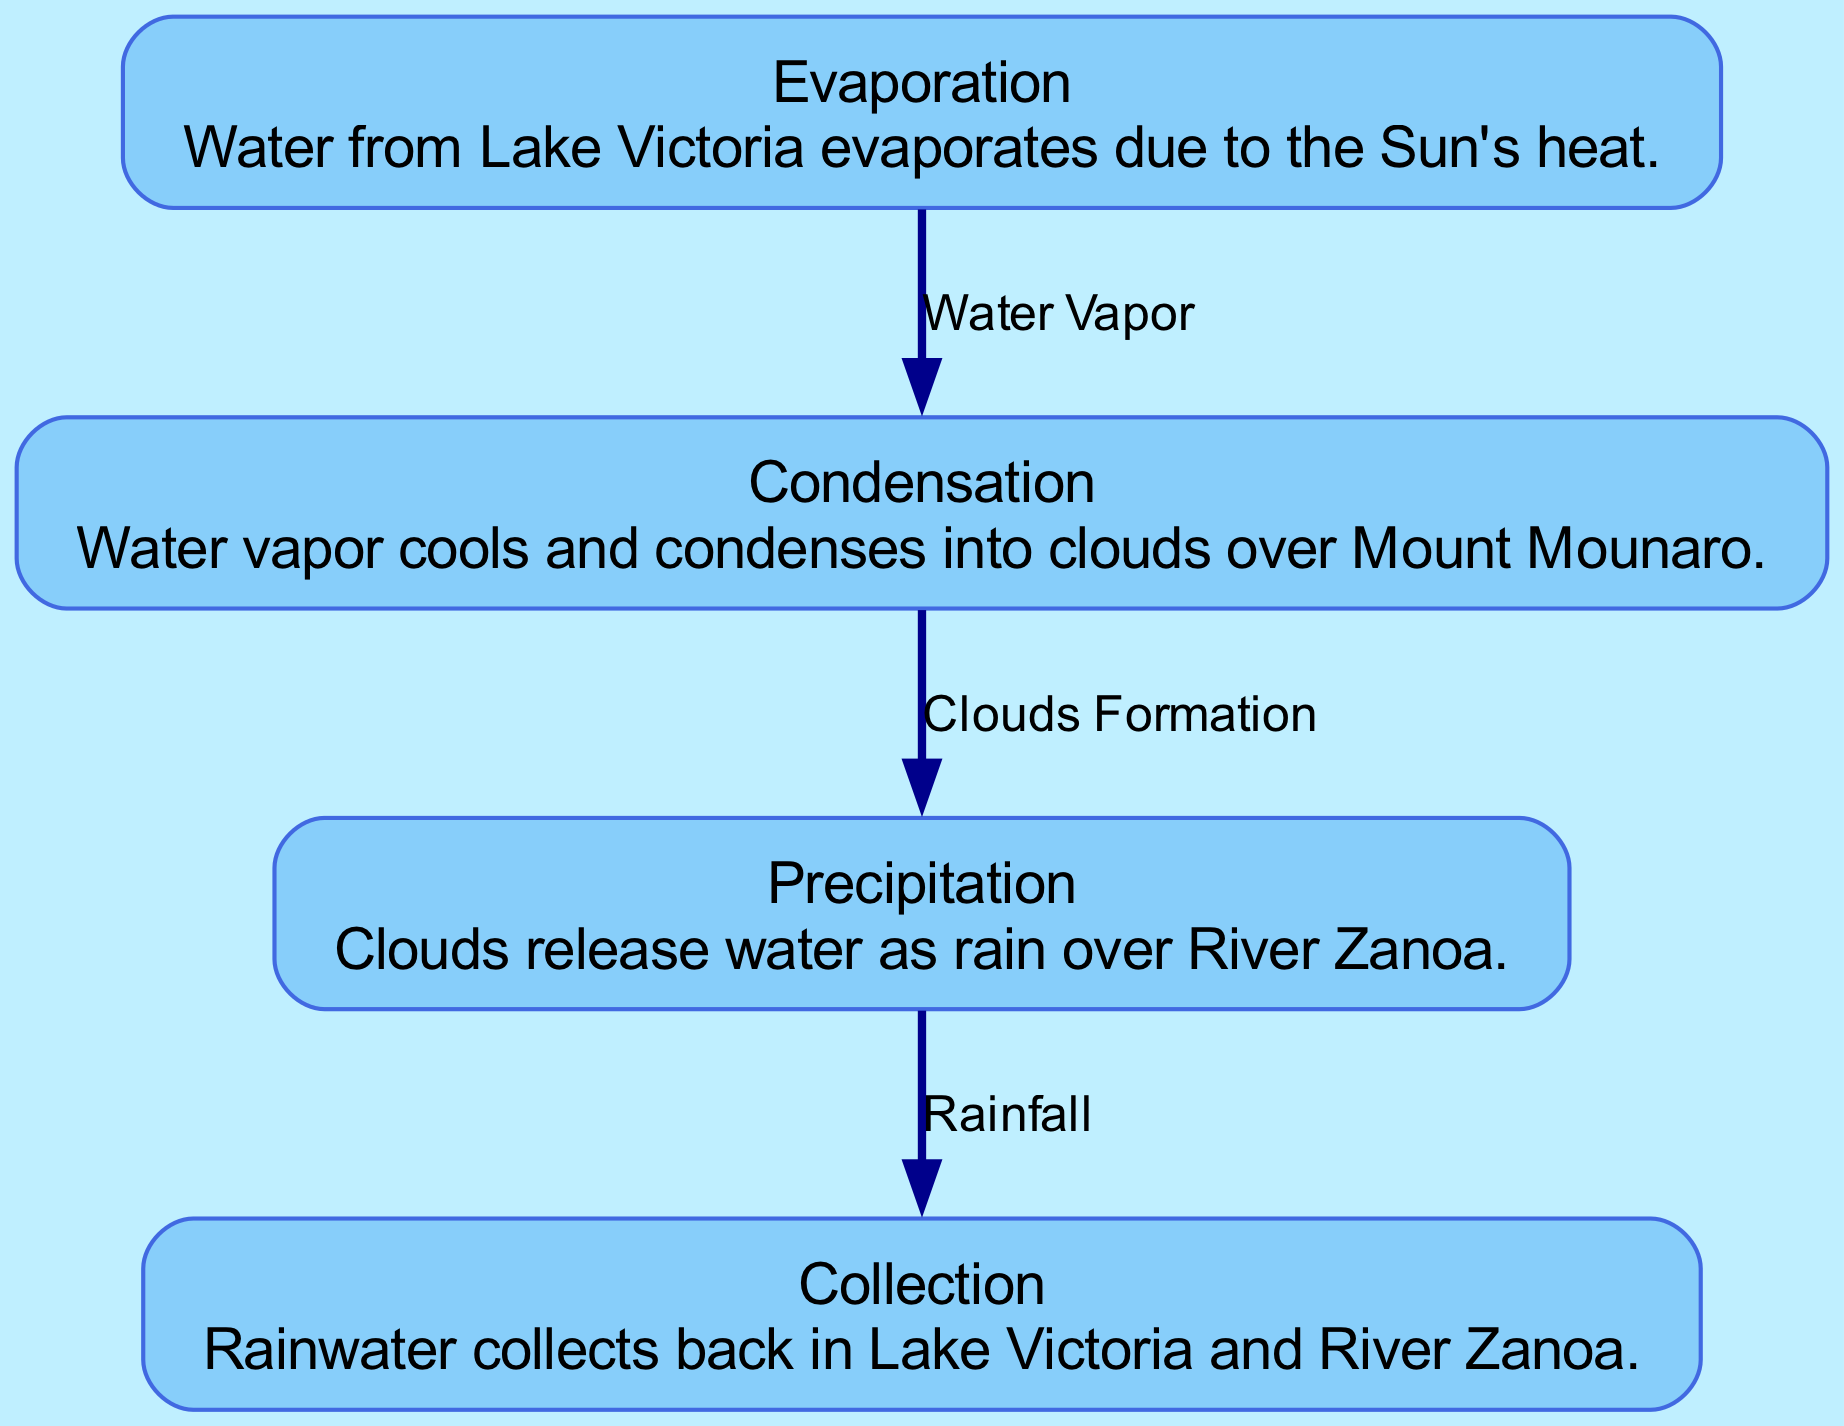What is the first process in the water cycle shown in the diagram? The first process listed in the nodes of the diagram is "Evaporation," which indicates that water evaporates from Lake Victoria due to the Sun's heat.
Answer: Evaporation How many nodes are depicted in the diagram? By counting the individual processes represented in the diagram, which are Evaporation, Condensation, Precipitation, and Collection, there are a total of four nodes.
Answer: 4 What do clouds form from in the water cycle? According to the edges in the diagram, clouds form from the "Water Vapor" produced during the Evaporation process.
Answer: Water Vapor Which local water source is mentioned during the precipitation process? The diagram specifically mentions "River Zanoa" in relation to the precipitation process, highlighting where clouds release water as rain.
Answer: River Zanoa Describe the final step in the local water cycle as shown in the diagram. The final step, captured in the "Collection" node, details that rainwater collects back into both Lake Victoria and River Zanoa, thus completing the cycle.
Answer: Lake Victoria and River Zanoa How does precipitation affect the local water sources mentioned? The diagram shows that precipitation is directly responsible for bringing rain over River Zanoa, which contributes to the replenishment of local water supply.
Answer: Rain replenishes local water supply What is the relationship between condensation and precipitation in the diagram? The relationship is indicated by the edge labeled "Clouds Formation," pointing from the "Condensation" node to the "Precipitation" node, signifying that condensation leads to precipitation.
Answer: Clouds Formation 